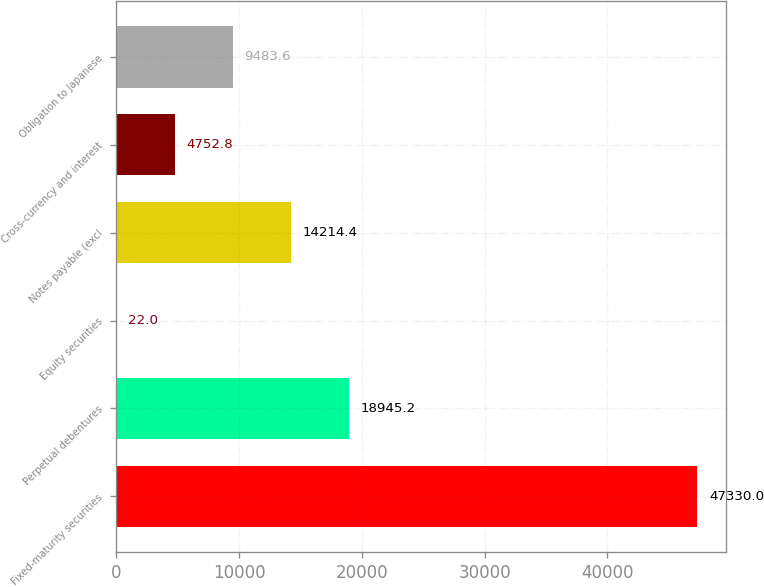Convert chart to OTSL. <chart><loc_0><loc_0><loc_500><loc_500><bar_chart><fcel>Fixed-maturity securities<fcel>Perpetual debentures<fcel>Equity securities<fcel>Notes payable (excl<fcel>Cross-currency and interest<fcel>Obligation to Japanese<nl><fcel>47330<fcel>18945.2<fcel>22<fcel>14214.4<fcel>4752.8<fcel>9483.6<nl></chart> 